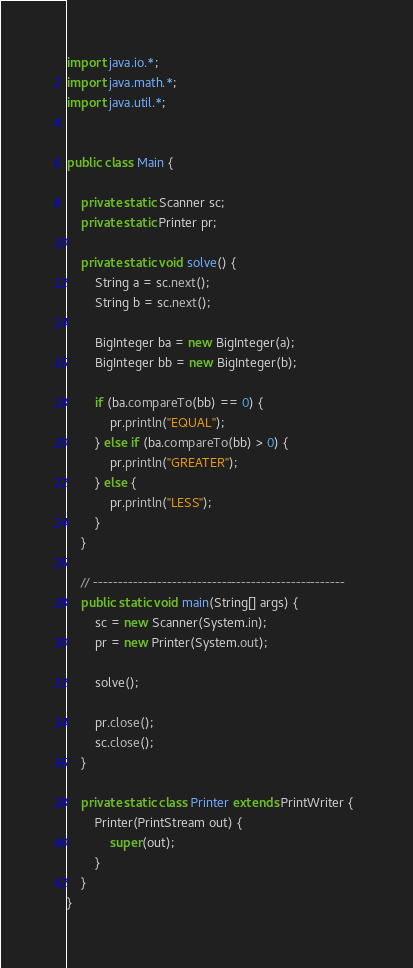<code> <loc_0><loc_0><loc_500><loc_500><_Java_>import java.io.*;
import java.math.*;
import java.util.*;


public class Main {

	private static Scanner sc;
	private static Printer pr;

	private static void solve() {
		String a = sc.next();
		String b = sc.next();

		BigInteger ba = new BigInteger(a);
		BigInteger bb = new BigInteger(b);

		if (ba.compareTo(bb) == 0) {
			pr.println("EQUAL");
		} else if (ba.compareTo(bb) > 0) {
			pr.println("GREATER");
		} else {
			pr.println("LESS");
		}
	}

	// ---------------------------------------------------
	public static void main(String[] args) {
		sc = new Scanner(System.in);
		pr = new Printer(System.out);

		solve();

		pr.close();
		sc.close();
	}

	private static class Printer extends PrintWriter {
		Printer(PrintStream out) {
			super(out);
		}
	}
}
</code> 